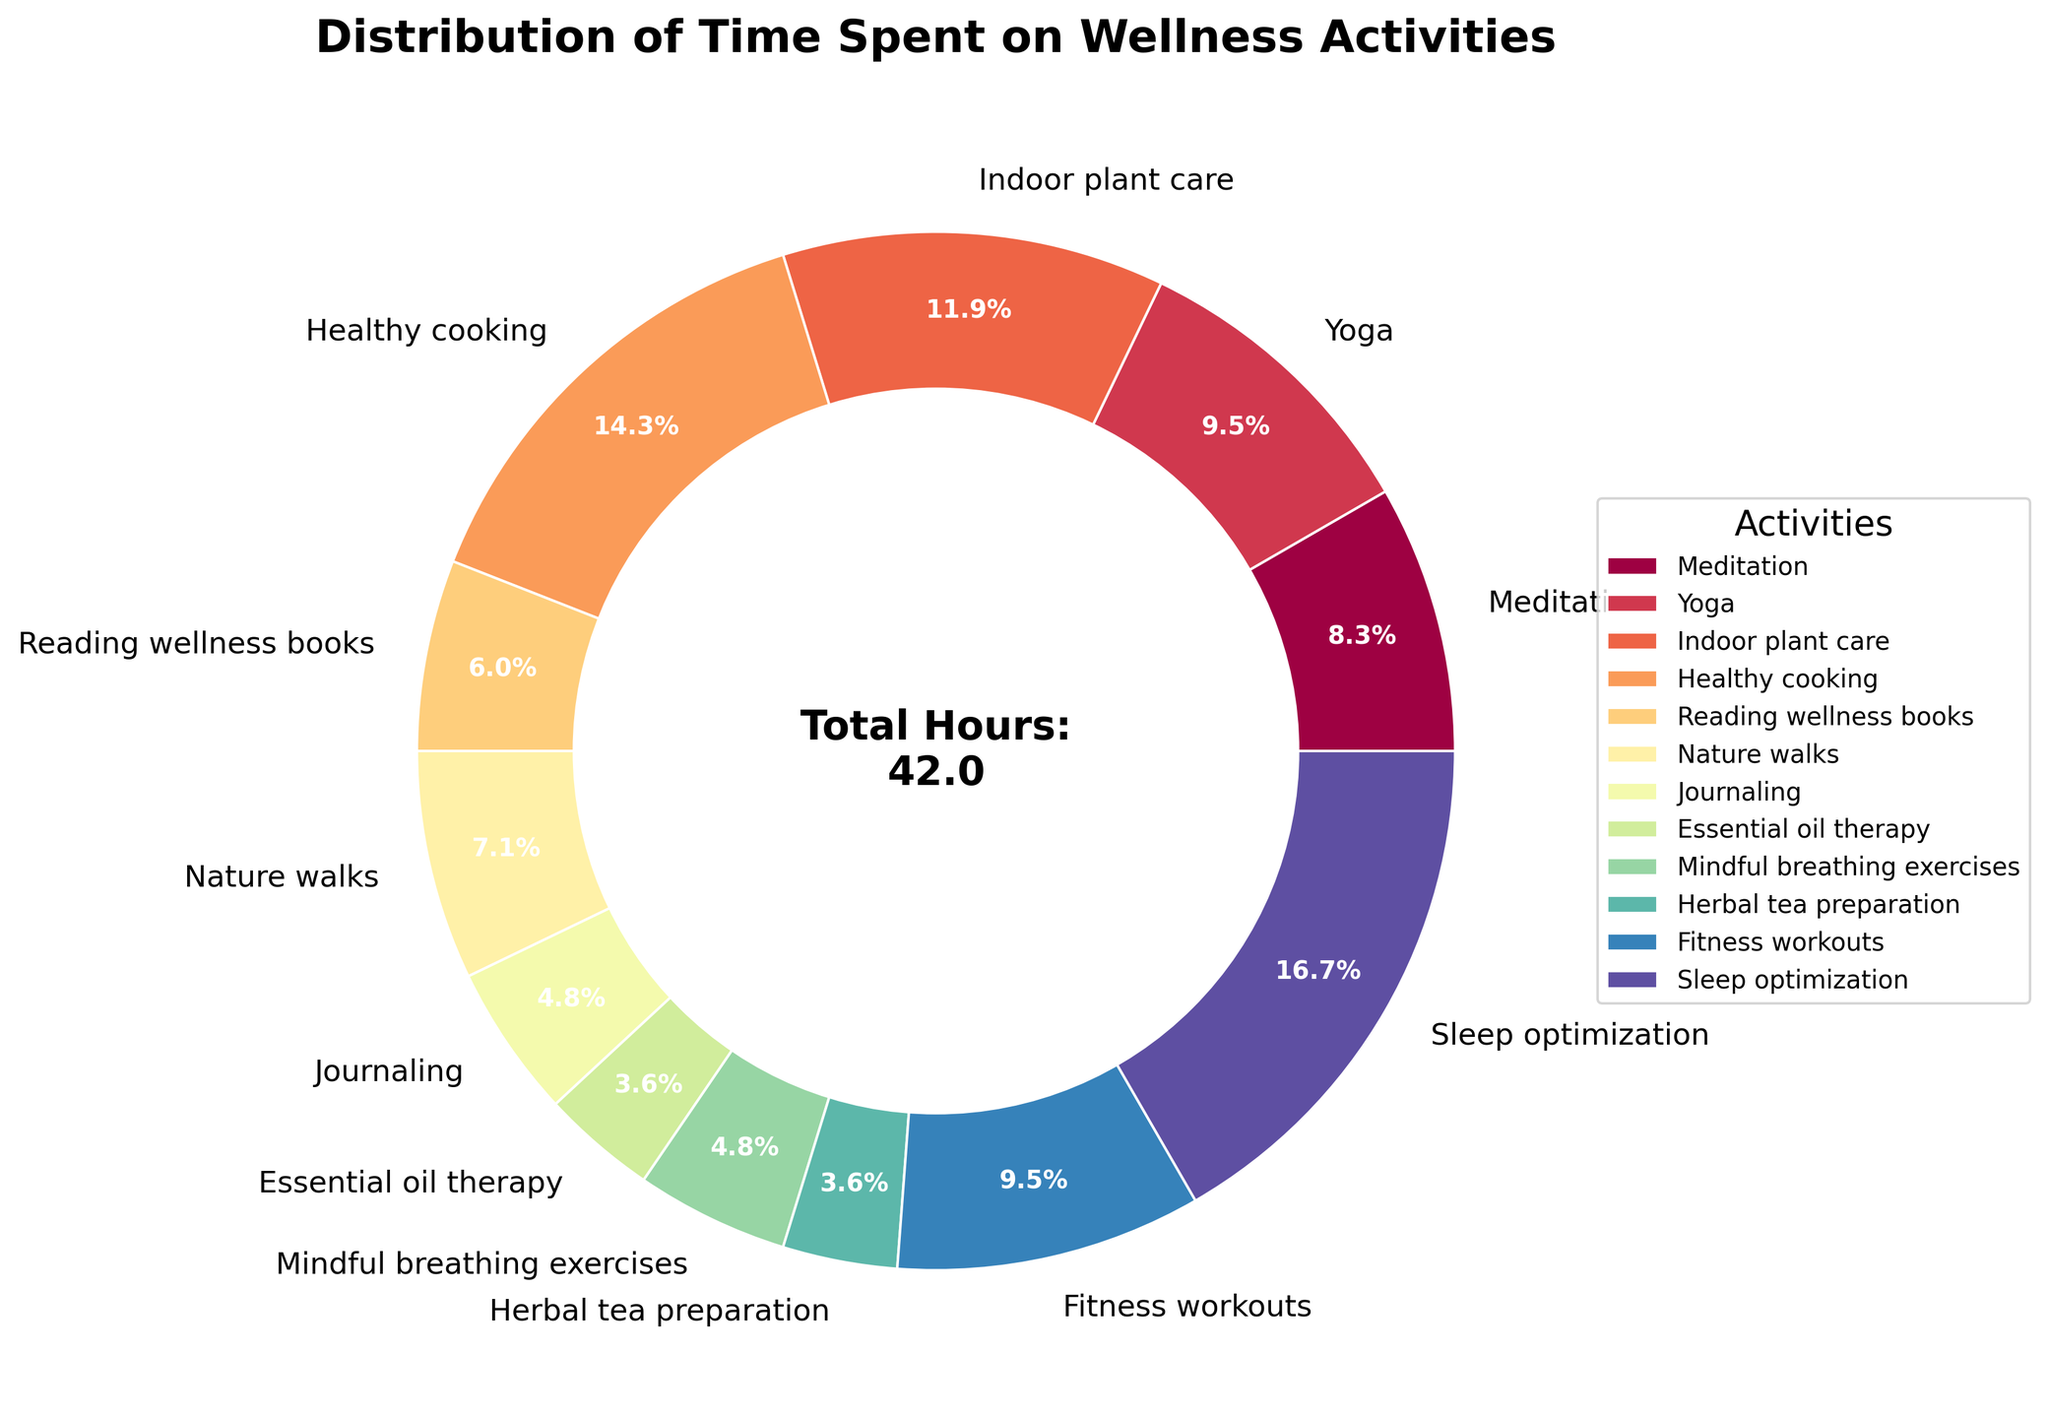What's the activity with the largest share of time? Looking at the pie chart, the largest wedge corresponds to "Sleep optimization."
Answer: Sleep optimization Which activities have an equal share of time spent per week? From the pie chart, "Essential oil therapy" and "Herbal tea preparation" both occupy the same proportion of the chart.
Answer: Essential oil therapy and Herbal tea preparation What percentage of time is spent on Indoor plant care? The pie chart shows a label with the percentage for "Indoor plant care," which is 11.9%.
Answer: 11.9% How much more time is spent on Healthy cooking compared to Meditation? Healthy cooking is 6 hours, while Meditation is 3.5 hours. The difference is 6 - 3.5 = 2.5 hours.
Answer: 2.5 hours What is the combined percentage for activities that involve physical exercise (Yoga and Fitness workouts)? Yoga is 9.5% and Fitness workouts are 9.5%. The total is 9.5% + 9.5% = 19%.
Answer: 19% Which activities together take up more time than Sleep optimization? Sleep optimization is 7 hours. "Healthy cooking" (6 hours) and "Indoor plant care" (5 hours) together make 6 + 5 = 11 hours, which is more than 7 hours.
Answer: Healthy cooking and Indoor plant care What is the total number of hours spent on activities related to mindfulness (Meditation, Journaling, Mindful breathing exercises)? Adding up the hours: Meditation (3.5) + Journaling (2) + Mindful breathing exercises (2) = 3.5 + 2 + 2 = 7.5 hours.
Answer: 7.5 hours Which activity has the smallest share of time, and what is its percentage? The smallest wedge in the pie chart corresponds to "Essential oil therapy," which is 1.8%.
Answer: Essential oil therapy, 1.8% 